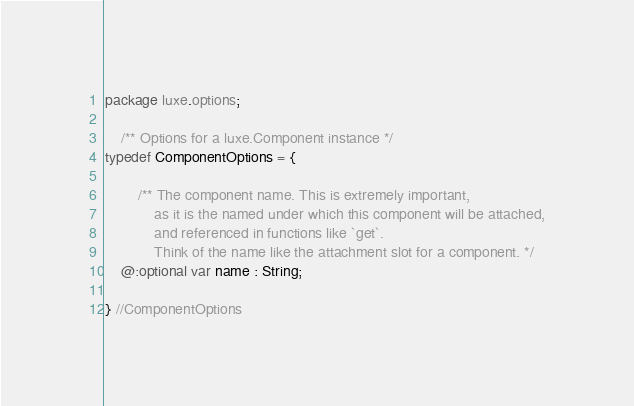Convert code to text. <code><loc_0><loc_0><loc_500><loc_500><_Haxe_>package luxe.options;

    /** Options for a luxe.Component instance */
typedef ComponentOptions = {

        /** The component name. This is extremely important,
            as it is the named under which this component will be attached,
            and referenced in functions like `get`.
            Think of the name like the attachment slot for a component. */
    @:optional var name : String;

} //ComponentOptions
</code> 